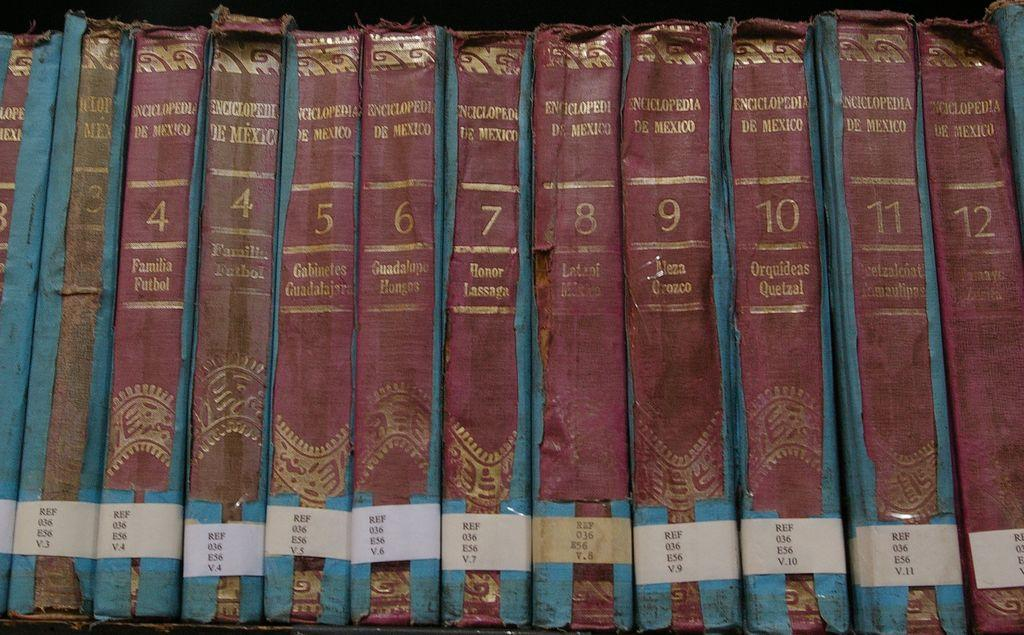<image>
Share a concise interpretation of the image provided. A row of worn book spines are lines up, showing two copies of volume 4 of an encyclopedia. 